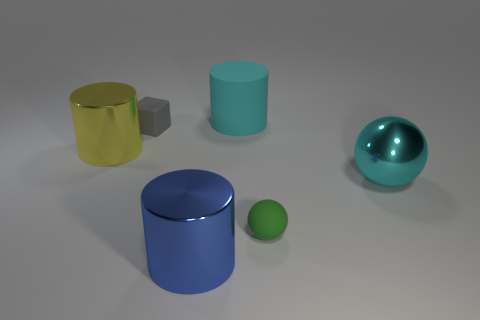Are there fewer blue cylinders that are behind the small gray rubber thing than large metallic spheres?
Provide a short and direct response. Yes. What number of rubber things are either big spheres or large cylinders?
Offer a very short reply. 1. Does the small ball have the same color as the large shiny ball?
Ensure brevity in your answer.  No. Are there any other things of the same color as the rubber cylinder?
Give a very brief answer. Yes. Is the shape of the cyan thing that is in front of the gray block the same as the tiny rubber object on the left side of the large cyan matte cylinder?
Your answer should be very brief. No. How many objects are gray objects or shiny things on the left side of the cyan rubber cylinder?
Your answer should be very brief. 3. How many other things are there of the same size as the blue shiny cylinder?
Provide a succinct answer. 3. Is the big thing that is on the left side of the blue shiny cylinder made of the same material as the cyan object to the left of the large shiny sphere?
Offer a very short reply. No. How many matte cylinders are in front of the large cyan metallic object?
Ensure brevity in your answer.  0. How many red objects are small cubes or metallic cylinders?
Your answer should be very brief. 0. 